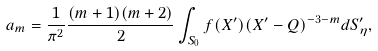Convert formula to latex. <formula><loc_0><loc_0><loc_500><loc_500>a _ { m } = \frac { 1 } { \pi ^ { 2 } } \frac { ( m + 1 ) ( m + 2 ) } { 2 } \int _ { S _ { 0 } } f ( X ^ { \prime } ) ( X ^ { \prime } - Q ) ^ { - 3 - m } d S _ { \eta } ^ { \prime } ,</formula> 